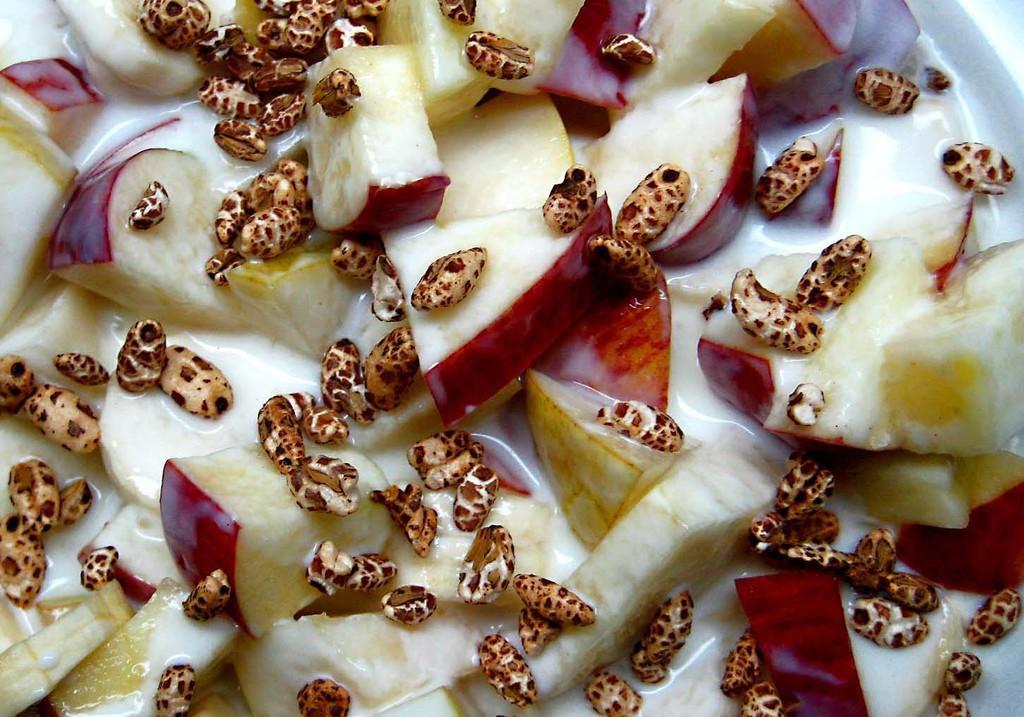How would you summarize this image in a sentence or two? In this picture we can see some slices of apples and some soup here. 